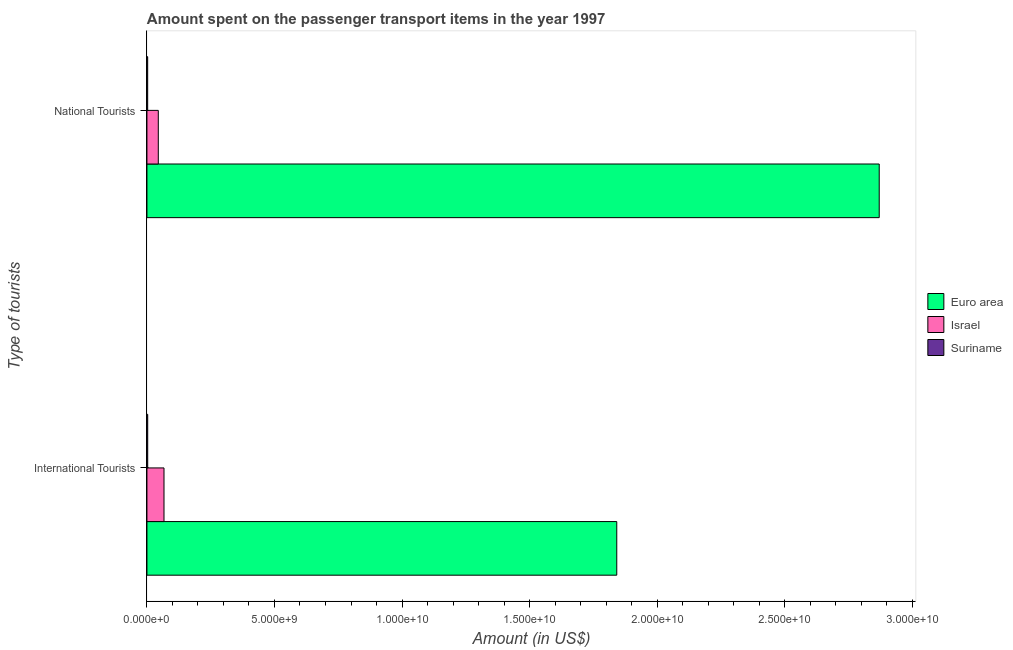How many groups of bars are there?
Provide a short and direct response. 2. Are the number of bars per tick equal to the number of legend labels?
Your response must be concise. Yes. How many bars are there on the 2nd tick from the top?
Your answer should be very brief. 3. What is the label of the 1st group of bars from the top?
Offer a very short reply. National Tourists. What is the amount spent on transport items of national tourists in Israel?
Your answer should be very brief. 4.45e+08. Across all countries, what is the maximum amount spent on transport items of national tourists?
Provide a short and direct response. 2.87e+1. Across all countries, what is the minimum amount spent on transport items of national tourists?
Provide a short and direct response. 2.90e+07. In which country was the amount spent on transport items of international tourists maximum?
Ensure brevity in your answer.  Euro area. In which country was the amount spent on transport items of national tourists minimum?
Provide a succinct answer. Suriname. What is the total amount spent on transport items of international tourists in the graph?
Your response must be concise. 1.91e+1. What is the difference between the amount spent on transport items of national tourists in Suriname and that in Israel?
Keep it short and to the point. -4.16e+08. What is the difference between the amount spent on transport items of international tourists in Euro area and the amount spent on transport items of national tourists in Israel?
Give a very brief answer. 1.80e+1. What is the average amount spent on transport items of national tourists per country?
Ensure brevity in your answer.  9.73e+09. What is the difference between the amount spent on transport items of national tourists and amount spent on transport items of international tourists in Israel?
Your response must be concise. -2.24e+08. What is the ratio of the amount spent on transport items of national tourists in Suriname to that in Israel?
Your response must be concise. 0.07. Is the amount spent on transport items of international tourists in Euro area less than that in Israel?
Offer a very short reply. No. In how many countries, is the amount spent on transport items of national tourists greater than the average amount spent on transport items of national tourists taken over all countries?
Give a very brief answer. 1. What does the 1st bar from the top in National Tourists represents?
Your response must be concise. Suriname. How many countries are there in the graph?
Offer a very short reply. 3. What is the difference between two consecutive major ticks on the X-axis?
Offer a terse response. 5.00e+09. Does the graph contain grids?
Make the answer very short. No. How many legend labels are there?
Ensure brevity in your answer.  3. How are the legend labels stacked?
Make the answer very short. Vertical. What is the title of the graph?
Keep it short and to the point. Amount spent on the passenger transport items in the year 1997. Does "Korea (Republic)" appear as one of the legend labels in the graph?
Provide a short and direct response. No. What is the label or title of the Y-axis?
Offer a terse response. Type of tourists. What is the Amount (in US$) of Euro area in International Tourists?
Offer a terse response. 1.84e+1. What is the Amount (in US$) in Israel in International Tourists?
Your answer should be compact. 6.69e+08. What is the Amount (in US$) in Suriname in International Tourists?
Keep it short and to the point. 3.00e+07. What is the Amount (in US$) of Euro area in National Tourists?
Your answer should be compact. 2.87e+1. What is the Amount (in US$) in Israel in National Tourists?
Ensure brevity in your answer.  4.45e+08. What is the Amount (in US$) of Suriname in National Tourists?
Your answer should be compact. 2.90e+07. Across all Type of tourists, what is the maximum Amount (in US$) in Euro area?
Give a very brief answer. 2.87e+1. Across all Type of tourists, what is the maximum Amount (in US$) in Israel?
Offer a very short reply. 6.69e+08. Across all Type of tourists, what is the maximum Amount (in US$) of Suriname?
Offer a very short reply. 3.00e+07. Across all Type of tourists, what is the minimum Amount (in US$) in Euro area?
Keep it short and to the point. 1.84e+1. Across all Type of tourists, what is the minimum Amount (in US$) in Israel?
Ensure brevity in your answer.  4.45e+08. Across all Type of tourists, what is the minimum Amount (in US$) of Suriname?
Give a very brief answer. 2.90e+07. What is the total Amount (in US$) in Euro area in the graph?
Provide a short and direct response. 4.71e+1. What is the total Amount (in US$) in Israel in the graph?
Ensure brevity in your answer.  1.11e+09. What is the total Amount (in US$) of Suriname in the graph?
Provide a succinct answer. 5.90e+07. What is the difference between the Amount (in US$) in Euro area in International Tourists and that in National Tourists?
Keep it short and to the point. -1.03e+1. What is the difference between the Amount (in US$) in Israel in International Tourists and that in National Tourists?
Keep it short and to the point. 2.24e+08. What is the difference between the Amount (in US$) in Suriname in International Tourists and that in National Tourists?
Keep it short and to the point. 1.00e+06. What is the difference between the Amount (in US$) of Euro area in International Tourists and the Amount (in US$) of Israel in National Tourists?
Your response must be concise. 1.80e+1. What is the difference between the Amount (in US$) of Euro area in International Tourists and the Amount (in US$) of Suriname in National Tourists?
Make the answer very short. 1.84e+1. What is the difference between the Amount (in US$) in Israel in International Tourists and the Amount (in US$) in Suriname in National Tourists?
Keep it short and to the point. 6.40e+08. What is the average Amount (in US$) of Euro area per Type of tourists?
Your answer should be compact. 2.36e+1. What is the average Amount (in US$) of Israel per Type of tourists?
Keep it short and to the point. 5.57e+08. What is the average Amount (in US$) of Suriname per Type of tourists?
Offer a very short reply. 2.95e+07. What is the difference between the Amount (in US$) of Euro area and Amount (in US$) of Israel in International Tourists?
Provide a short and direct response. 1.77e+1. What is the difference between the Amount (in US$) of Euro area and Amount (in US$) of Suriname in International Tourists?
Provide a short and direct response. 1.84e+1. What is the difference between the Amount (in US$) of Israel and Amount (in US$) of Suriname in International Tourists?
Offer a very short reply. 6.39e+08. What is the difference between the Amount (in US$) of Euro area and Amount (in US$) of Israel in National Tourists?
Your answer should be very brief. 2.83e+1. What is the difference between the Amount (in US$) of Euro area and Amount (in US$) of Suriname in National Tourists?
Offer a very short reply. 2.87e+1. What is the difference between the Amount (in US$) in Israel and Amount (in US$) in Suriname in National Tourists?
Ensure brevity in your answer.  4.16e+08. What is the ratio of the Amount (in US$) in Euro area in International Tourists to that in National Tourists?
Offer a very short reply. 0.64. What is the ratio of the Amount (in US$) in Israel in International Tourists to that in National Tourists?
Offer a very short reply. 1.5. What is the ratio of the Amount (in US$) of Suriname in International Tourists to that in National Tourists?
Provide a succinct answer. 1.03. What is the difference between the highest and the second highest Amount (in US$) of Euro area?
Make the answer very short. 1.03e+1. What is the difference between the highest and the second highest Amount (in US$) in Israel?
Your answer should be compact. 2.24e+08. What is the difference between the highest and the second highest Amount (in US$) in Suriname?
Your response must be concise. 1.00e+06. What is the difference between the highest and the lowest Amount (in US$) in Euro area?
Offer a very short reply. 1.03e+1. What is the difference between the highest and the lowest Amount (in US$) in Israel?
Provide a succinct answer. 2.24e+08. 